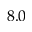<formula> <loc_0><loc_0><loc_500><loc_500>8 . 0</formula> 